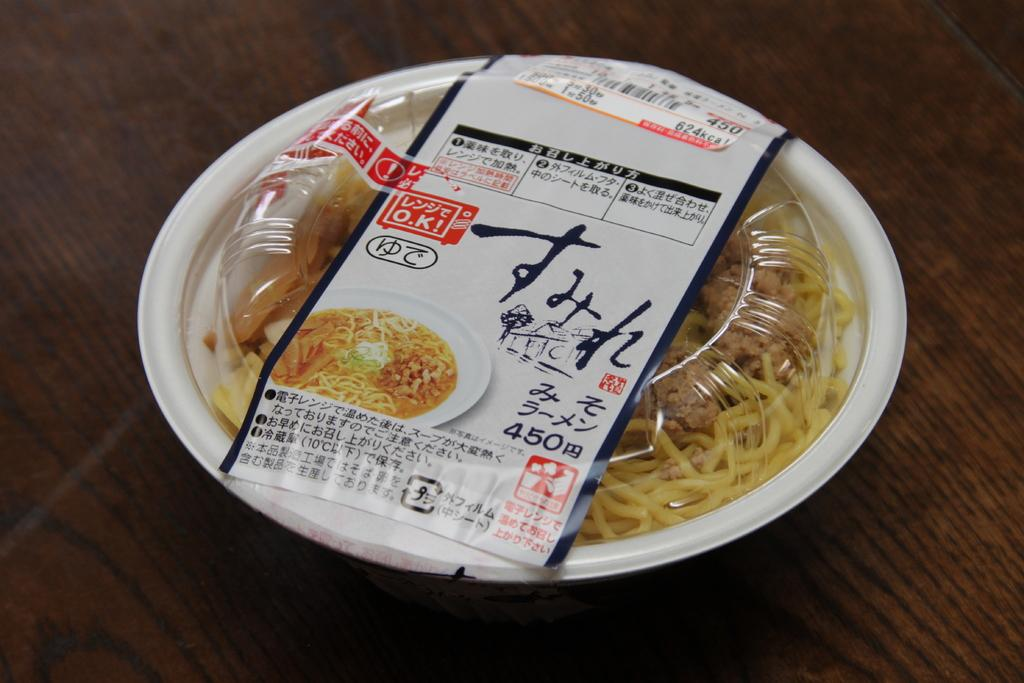What is the main object in the image? There is a food box in the image. Where is the food box located? The food box is placed on a table. What is the color of the table? The table is brown in color. How many giraffes can be seen standing near the food box in the image? There are no giraffes present in the image. What type of boot is placed on the table next to the food box? There is no boot present in the image. 